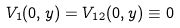Convert formula to latex. <formula><loc_0><loc_0><loc_500><loc_500>V _ { 1 } ( 0 , y ) = V _ { 1 2 } ( 0 , y ) \equiv 0</formula> 